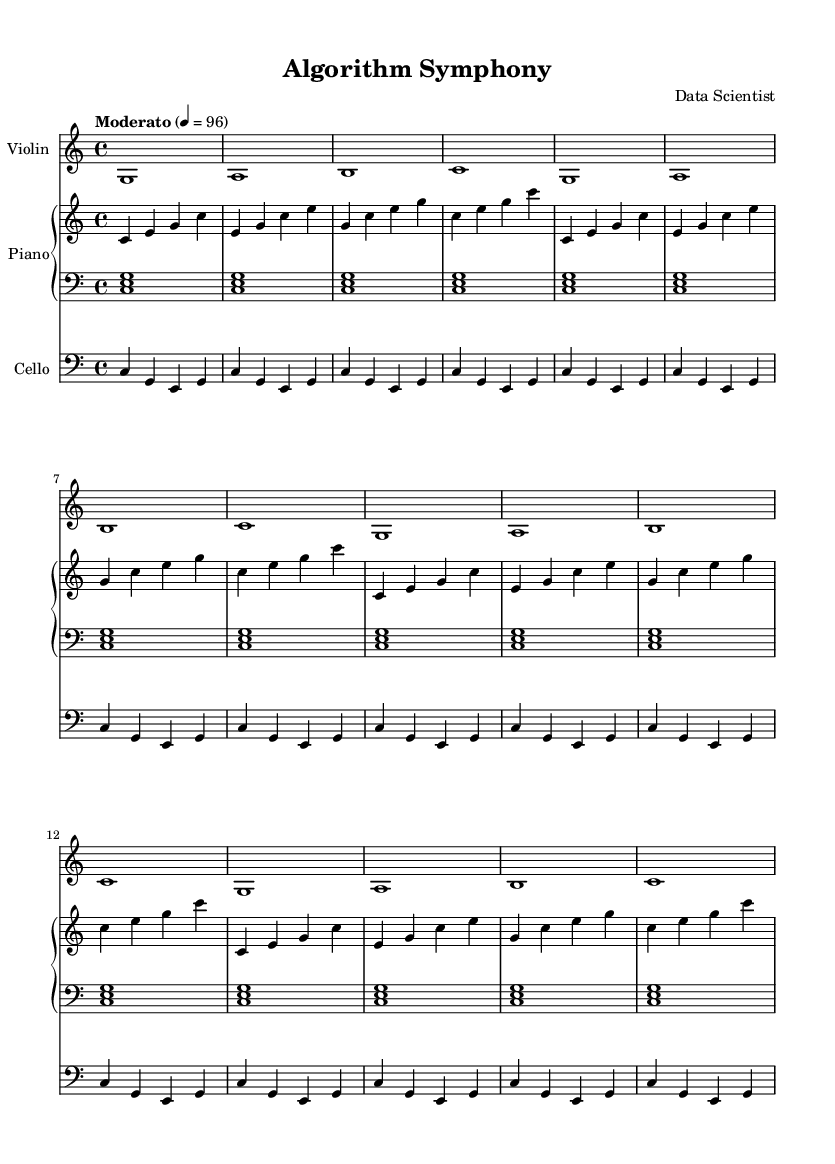What is the key signature of this music? The key signature is C major, which has no sharps or flats.
Answer: C major What is the time signature of the piece? The time signature is indicated at the beginning of the score, showing four beats per measure, typical for classical music.
Answer: 4/4 What is the tempo marking of the composition? The tempo marking is "Moderato," which indicates a moderate pace of play. Additionally, the number 96 specifies the beats per minute (BPM).
Answer: Moderato How many measures are in the right hand of the piano part? The right hand of the piano part consists of four repeated measures, which implies that there are a total of four measures as per the repeat indication "repeat unfold 4."
Answer: 4 What is the lowest note played by the cello? The cello plays a series of notes starting from C, which is the lowest note in the given snippet.
Answer: C How many instruments are used in this composition? The score consists of four unique parts: one for the violin, two for the piano (right and left hand), and one for the cello. Therefore, there are four instruments featured in the composition.
Answer: 4 What is the rhythmic pattern of the cello part? The cello part primarily consists of eighth notes grouped in repetitive patterns. Each measure contains a consistent rhythmic pattern of two half notes alternating with notes. This structure implies a predictable and algorithmic approach, characteristic of minimalist compositions.
Answer: Repetitive half notes 